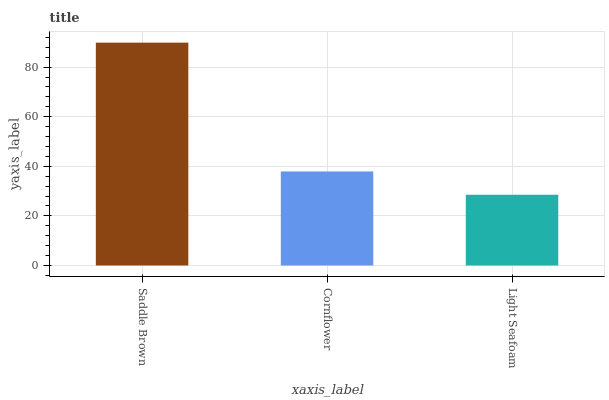Is Light Seafoam the minimum?
Answer yes or no. Yes. Is Saddle Brown the maximum?
Answer yes or no. Yes. Is Cornflower the minimum?
Answer yes or no. No. Is Cornflower the maximum?
Answer yes or no. No. Is Saddle Brown greater than Cornflower?
Answer yes or no. Yes. Is Cornflower less than Saddle Brown?
Answer yes or no. Yes. Is Cornflower greater than Saddle Brown?
Answer yes or no. No. Is Saddle Brown less than Cornflower?
Answer yes or no. No. Is Cornflower the high median?
Answer yes or no. Yes. Is Cornflower the low median?
Answer yes or no. Yes. Is Light Seafoam the high median?
Answer yes or no. No. Is Saddle Brown the low median?
Answer yes or no. No. 